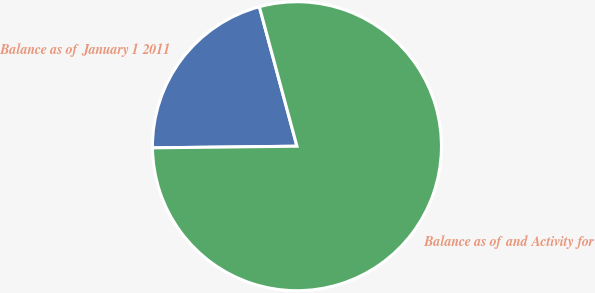Convert chart. <chart><loc_0><loc_0><loc_500><loc_500><pie_chart><fcel>Balance as of January 1 2011<fcel>Balance as of and Activity for<nl><fcel>20.99%<fcel>79.01%<nl></chart> 